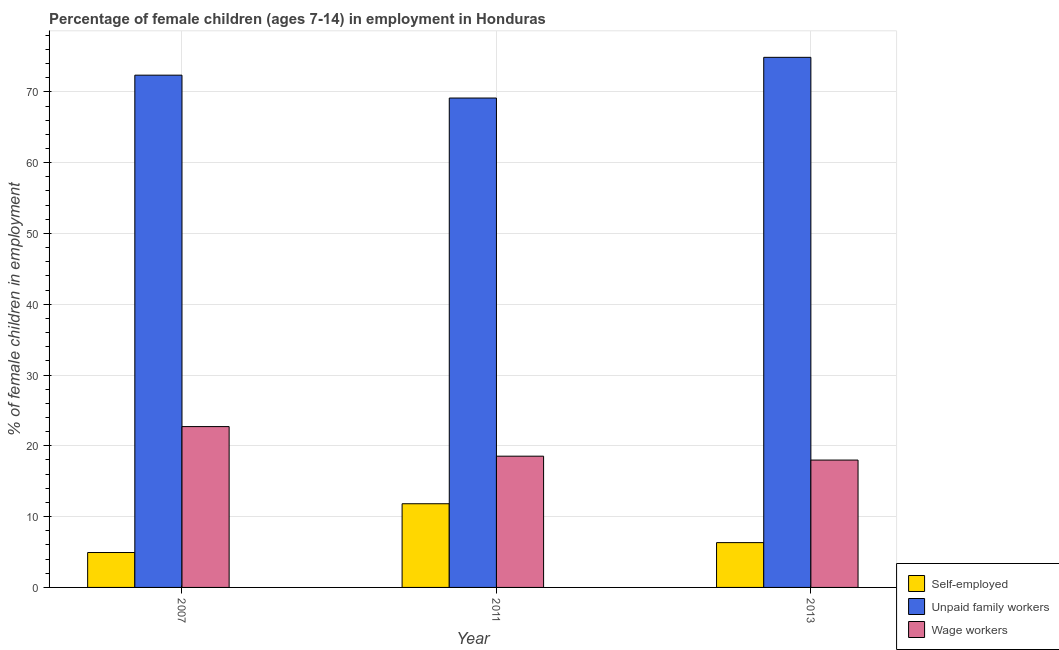How many different coloured bars are there?
Offer a very short reply. 3. What is the label of the 2nd group of bars from the left?
Ensure brevity in your answer.  2011. In how many cases, is the number of bars for a given year not equal to the number of legend labels?
Provide a short and direct response. 0. What is the percentage of children employed as unpaid family workers in 2007?
Your answer should be compact. 72.36. Across all years, what is the maximum percentage of children employed as unpaid family workers?
Offer a very short reply. 74.88. Across all years, what is the minimum percentage of children employed as wage workers?
Make the answer very short. 17.99. In which year was the percentage of self employed children maximum?
Your response must be concise. 2011. In which year was the percentage of children employed as wage workers minimum?
Offer a terse response. 2013. What is the total percentage of self employed children in the graph?
Your answer should be compact. 23.08. What is the difference between the percentage of children employed as unpaid family workers in 2007 and that in 2013?
Offer a terse response. -2.52. What is the difference between the percentage of self employed children in 2007 and the percentage of children employed as unpaid family workers in 2011?
Provide a succinct answer. -6.89. What is the average percentage of children employed as wage workers per year?
Keep it short and to the point. 19.75. In how many years, is the percentage of children employed as unpaid family workers greater than 20 %?
Give a very brief answer. 3. What is the ratio of the percentage of children employed as unpaid family workers in 2007 to that in 2011?
Your answer should be compact. 1.05. Is the percentage of children employed as unpaid family workers in 2007 less than that in 2013?
Offer a terse response. Yes. Is the difference between the percentage of children employed as unpaid family workers in 2007 and 2011 greater than the difference between the percentage of self employed children in 2007 and 2011?
Provide a succinct answer. No. What is the difference between the highest and the second highest percentage of children employed as unpaid family workers?
Offer a terse response. 2.52. What is the difference between the highest and the lowest percentage of children employed as unpaid family workers?
Your answer should be compact. 5.75. In how many years, is the percentage of children employed as unpaid family workers greater than the average percentage of children employed as unpaid family workers taken over all years?
Ensure brevity in your answer.  2. What does the 3rd bar from the left in 2011 represents?
Provide a short and direct response. Wage workers. What does the 3rd bar from the right in 2007 represents?
Offer a terse response. Self-employed. Is it the case that in every year, the sum of the percentage of self employed children and percentage of children employed as unpaid family workers is greater than the percentage of children employed as wage workers?
Offer a terse response. Yes. How many bars are there?
Offer a terse response. 9. Are all the bars in the graph horizontal?
Your answer should be compact. No. How many years are there in the graph?
Your response must be concise. 3. What is the difference between two consecutive major ticks on the Y-axis?
Your answer should be very brief. 10. Are the values on the major ticks of Y-axis written in scientific E-notation?
Make the answer very short. No. How many legend labels are there?
Give a very brief answer. 3. What is the title of the graph?
Provide a succinct answer. Percentage of female children (ages 7-14) in employment in Honduras. What is the label or title of the X-axis?
Make the answer very short. Year. What is the label or title of the Y-axis?
Keep it short and to the point. % of female children in employment. What is the % of female children in employment in Self-employed in 2007?
Provide a succinct answer. 4.93. What is the % of female children in employment of Unpaid family workers in 2007?
Keep it short and to the point. 72.36. What is the % of female children in employment of Wage workers in 2007?
Offer a very short reply. 22.72. What is the % of female children in employment of Self-employed in 2011?
Keep it short and to the point. 11.82. What is the % of female children in employment of Unpaid family workers in 2011?
Provide a succinct answer. 69.13. What is the % of female children in employment of Wage workers in 2011?
Ensure brevity in your answer.  18.54. What is the % of female children in employment in Self-employed in 2013?
Make the answer very short. 6.33. What is the % of female children in employment in Unpaid family workers in 2013?
Provide a succinct answer. 74.88. What is the % of female children in employment of Wage workers in 2013?
Provide a short and direct response. 17.99. Across all years, what is the maximum % of female children in employment in Self-employed?
Ensure brevity in your answer.  11.82. Across all years, what is the maximum % of female children in employment of Unpaid family workers?
Ensure brevity in your answer.  74.88. Across all years, what is the maximum % of female children in employment of Wage workers?
Your answer should be compact. 22.72. Across all years, what is the minimum % of female children in employment in Self-employed?
Your answer should be compact. 4.93. Across all years, what is the minimum % of female children in employment of Unpaid family workers?
Keep it short and to the point. 69.13. Across all years, what is the minimum % of female children in employment of Wage workers?
Provide a succinct answer. 17.99. What is the total % of female children in employment in Self-employed in the graph?
Your response must be concise. 23.08. What is the total % of female children in employment in Unpaid family workers in the graph?
Give a very brief answer. 216.37. What is the total % of female children in employment in Wage workers in the graph?
Your response must be concise. 59.25. What is the difference between the % of female children in employment of Self-employed in 2007 and that in 2011?
Keep it short and to the point. -6.89. What is the difference between the % of female children in employment of Unpaid family workers in 2007 and that in 2011?
Your response must be concise. 3.23. What is the difference between the % of female children in employment in Wage workers in 2007 and that in 2011?
Give a very brief answer. 4.18. What is the difference between the % of female children in employment of Unpaid family workers in 2007 and that in 2013?
Provide a succinct answer. -2.52. What is the difference between the % of female children in employment in Wage workers in 2007 and that in 2013?
Your answer should be very brief. 4.73. What is the difference between the % of female children in employment in Self-employed in 2011 and that in 2013?
Give a very brief answer. 5.49. What is the difference between the % of female children in employment in Unpaid family workers in 2011 and that in 2013?
Offer a terse response. -5.75. What is the difference between the % of female children in employment of Wage workers in 2011 and that in 2013?
Offer a very short reply. 0.55. What is the difference between the % of female children in employment of Self-employed in 2007 and the % of female children in employment of Unpaid family workers in 2011?
Your answer should be compact. -64.2. What is the difference between the % of female children in employment in Self-employed in 2007 and the % of female children in employment in Wage workers in 2011?
Ensure brevity in your answer.  -13.61. What is the difference between the % of female children in employment of Unpaid family workers in 2007 and the % of female children in employment of Wage workers in 2011?
Make the answer very short. 53.82. What is the difference between the % of female children in employment in Self-employed in 2007 and the % of female children in employment in Unpaid family workers in 2013?
Offer a terse response. -69.95. What is the difference between the % of female children in employment of Self-employed in 2007 and the % of female children in employment of Wage workers in 2013?
Provide a succinct answer. -13.06. What is the difference between the % of female children in employment in Unpaid family workers in 2007 and the % of female children in employment in Wage workers in 2013?
Provide a short and direct response. 54.37. What is the difference between the % of female children in employment of Self-employed in 2011 and the % of female children in employment of Unpaid family workers in 2013?
Ensure brevity in your answer.  -63.06. What is the difference between the % of female children in employment in Self-employed in 2011 and the % of female children in employment in Wage workers in 2013?
Your response must be concise. -6.17. What is the difference between the % of female children in employment of Unpaid family workers in 2011 and the % of female children in employment of Wage workers in 2013?
Keep it short and to the point. 51.14. What is the average % of female children in employment in Self-employed per year?
Your answer should be compact. 7.69. What is the average % of female children in employment of Unpaid family workers per year?
Provide a succinct answer. 72.12. What is the average % of female children in employment of Wage workers per year?
Your response must be concise. 19.75. In the year 2007, what is the difference between the % of female children in employment of Self-employed and % of female children in employment of Unpaid family workers?
Make the answer very short. -67.43. In the year 2007, what is the difference between the % of female children in employment of Self-employed and % of female children in employment of Wage workers?
Make the answer very short. -17.79. In the year 2007, what is the difference between the % of female children in employment of Unpaid family workers and % of female children in employment of Wage workers?
Your response must be concise. 49.64. In the year 2011, what is the difference between the % of female children in employment of Self-employed and % of female children in employment of Unpaid family workers?
Give a very brief answer. -57.31. In the year 2011, what is the difference between the % of female children in employment in Self-employed and % of female children in employment in Wage workers?
Your answer should be very brief. -6.72. In the year 2011, what is the difference between the % of female children in employment in Unpaid family workers and % of female children in employment in Wage workers?
Provide a short and direct response. 50.59. In the year 2013, what is the difference between the % of female children in employment in Self-employed and % of female children in employment in Unpaid family workers?
Your answer should be compact. -68.55. In the year 2013, what is the difference between the % of female children in employment in Self-employed and % of female children in employment in Wage workers?
Ensure brevity in your answer.  -11.66. In the year 2013, what is the difference between the % of female children in employment of Unpaid family workers and % of female children in employment of Wage workers?
Keep it short and to the point. 56.89. What is the ratio of the % of female children in employment in Self-employed in 2007 to that in 2011?
Offer a terse response. 0.42. What is the ratio of the % of female children in employment in Unpaid family workers in 2007 to that in 2011?
Ensure brevity in your answer.  1.05. What is the ratio of the % of female children in employment in Wage workers in 2007 to that in 2011?
Offer a terse response. 1.23. What is the ratio of the % of female children in employment in Self-employed in 2007 to that in 2013?
Make the answer very short. 0.78. What is the ratio of the % of female children in employment in Unpaid family workers in 2007 to that in 2013?
Provide a succinct answer. 0.97. What is the ratio of the % of female children in employment of Wage workers in 2007 to that in 2013?
Your response must be concise. 1.26. What is the ratio of the % of female children in employment of Self-employed in 2011 to that in 2013?
Make the answer very short. 1.87. What is the ratio of the % of female children in employment in Unpaid family workers in 2011 to that in 2013?
Your response must be concise. 0.92. What is the ratio of the % of female children in employment of Wage workers in 2011 to that in 2013?
Your answer should be very brief. 1.03. What is the difference between the highest and the second highest % of female children in employment of Self-employed?
Offer a very short reply. 5.49. What is the difference between the highest and the second highest % of female children in employment in Unpaid family workers?
Keep it short and to the point. 2.52. What is the difference between the highest and the second highest % of female children in employment of Wage workers?
Provide a short and direct response. 4.18. What is the difference between the highest and the lowest % of female children in employment of Self-employed?
Your answer should be very brief. 6.89. What is the difference between the highest and the lowest % of female children in employment of Unpaid family workers?
Your answer should be very brief. 5.75. What is the difference between the highest and the lowest % of female children in employment of Wage workers?
Your answer should be compact. 4.73. 